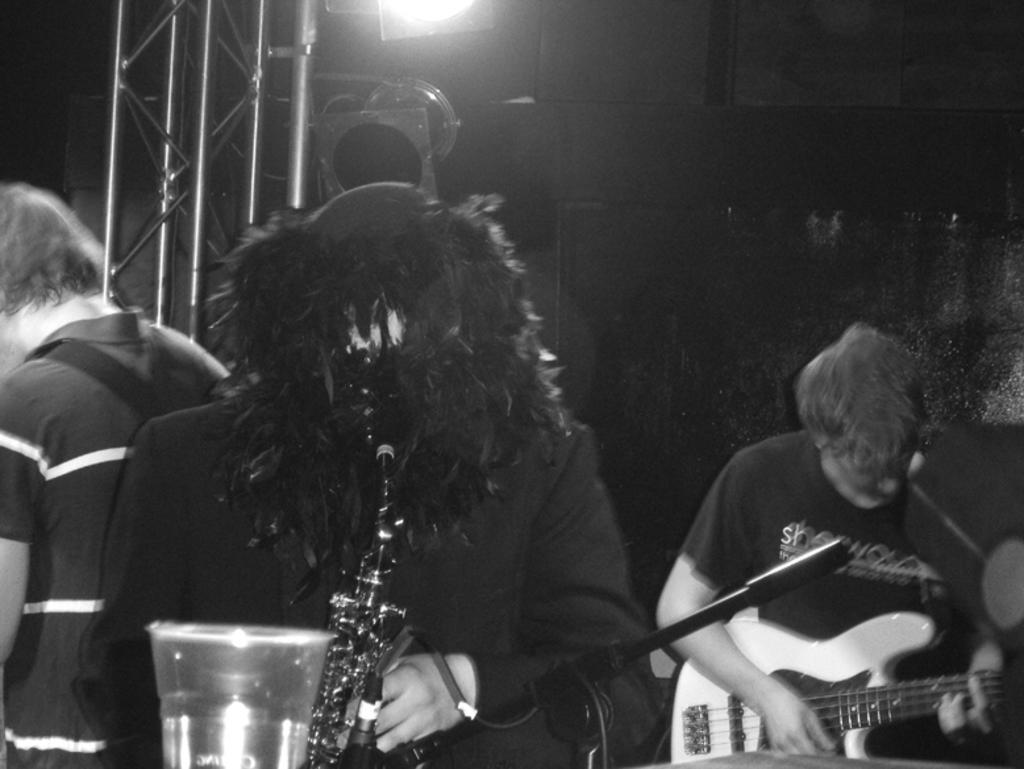Describe this image in one or two sentences. In this image I see 3 persons, in which 2 of them are holding the musical instruments. In the background I see the light. 